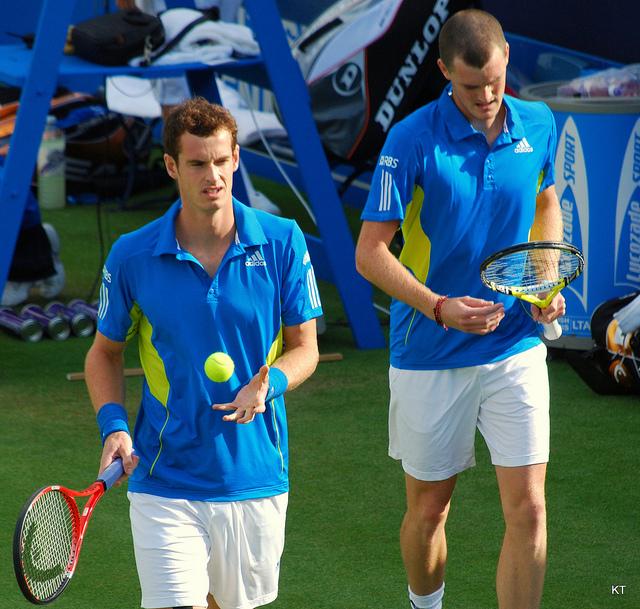Is this practice or a match?
Quick response, please. Match. Are two men wearing the same outfit?
Answer briefly. Yes. What sport are they playing?
Be succinct. Tennis. 